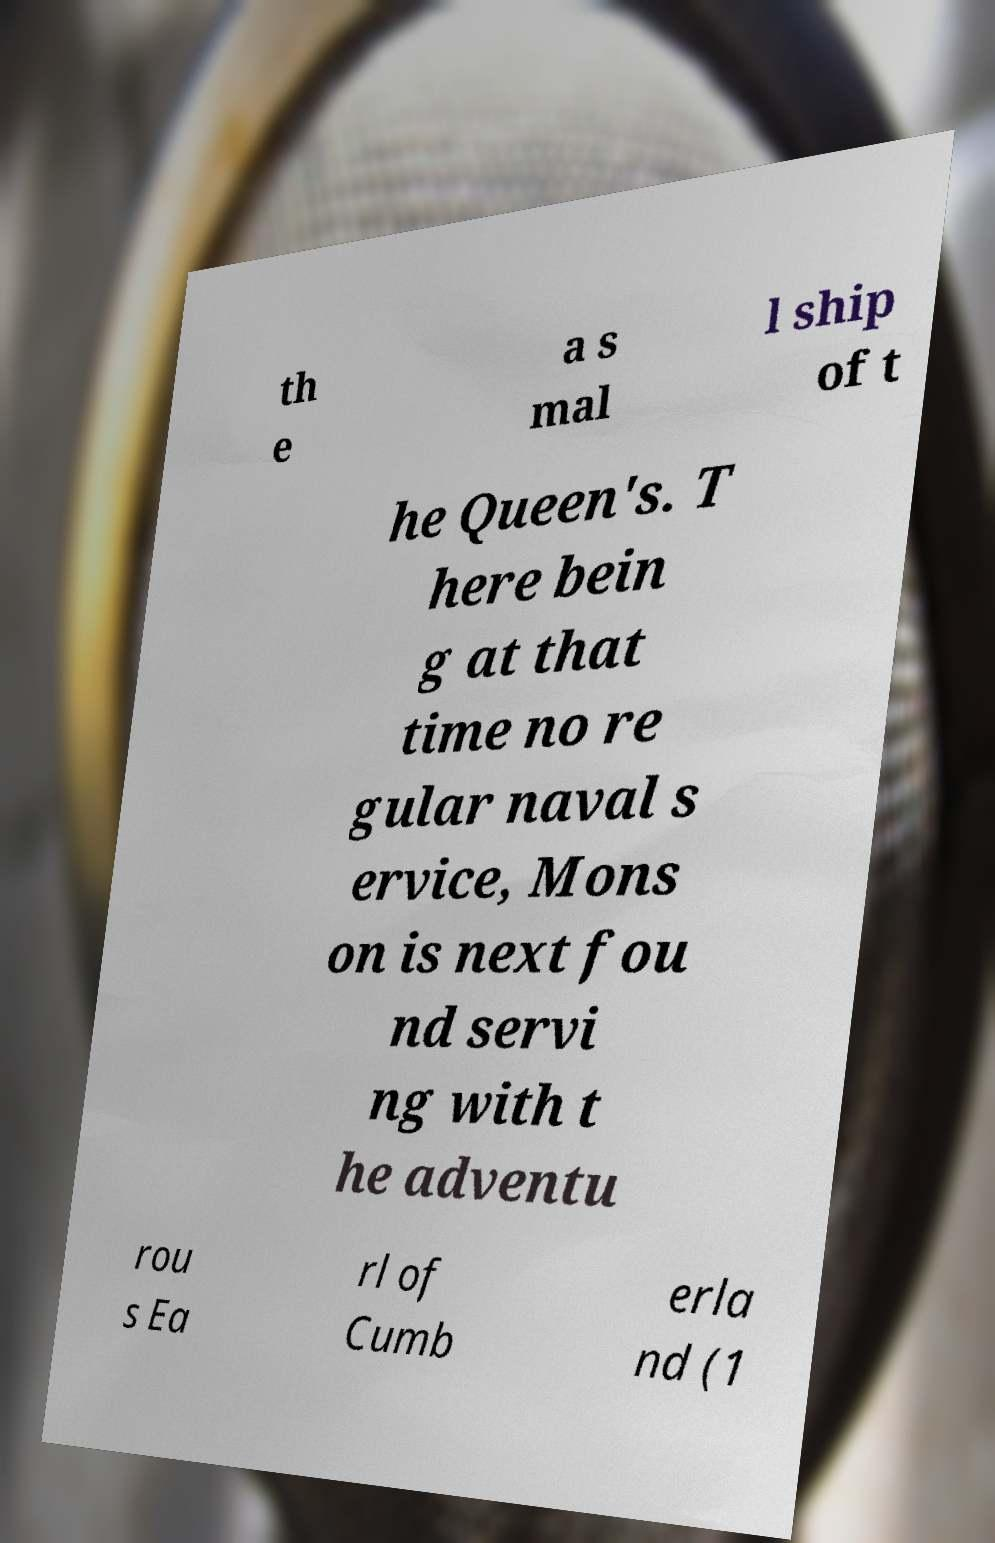Please read and relay the text visible in this image. What does it say? th e a s mal l ship of t he Queen's. T here bein g at that time no re gular naval s ervice, Mons on is next fou nd servi ng with t he adventu rou s Ea rl of Cumb erla nd (1 